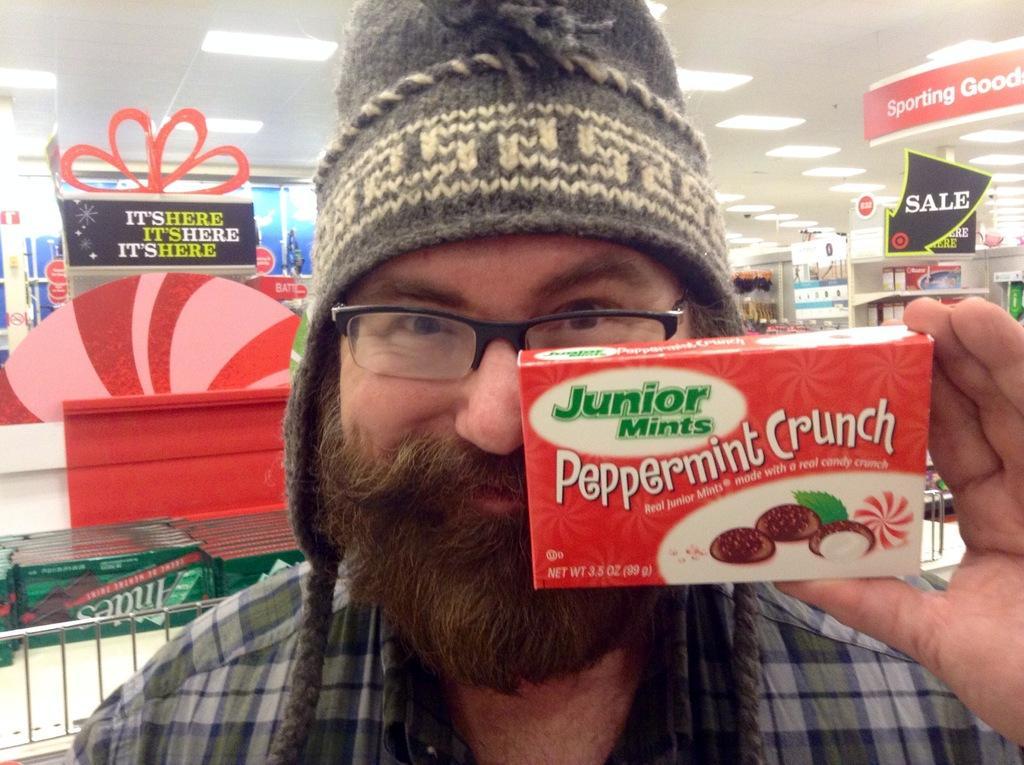In one or two sentences, can you explain what this image depicts? This image is taken in the store. In the center of the image we can see a person holding a box. In the background there are shelves and some objects placed in it and we can see some lights at the top. 